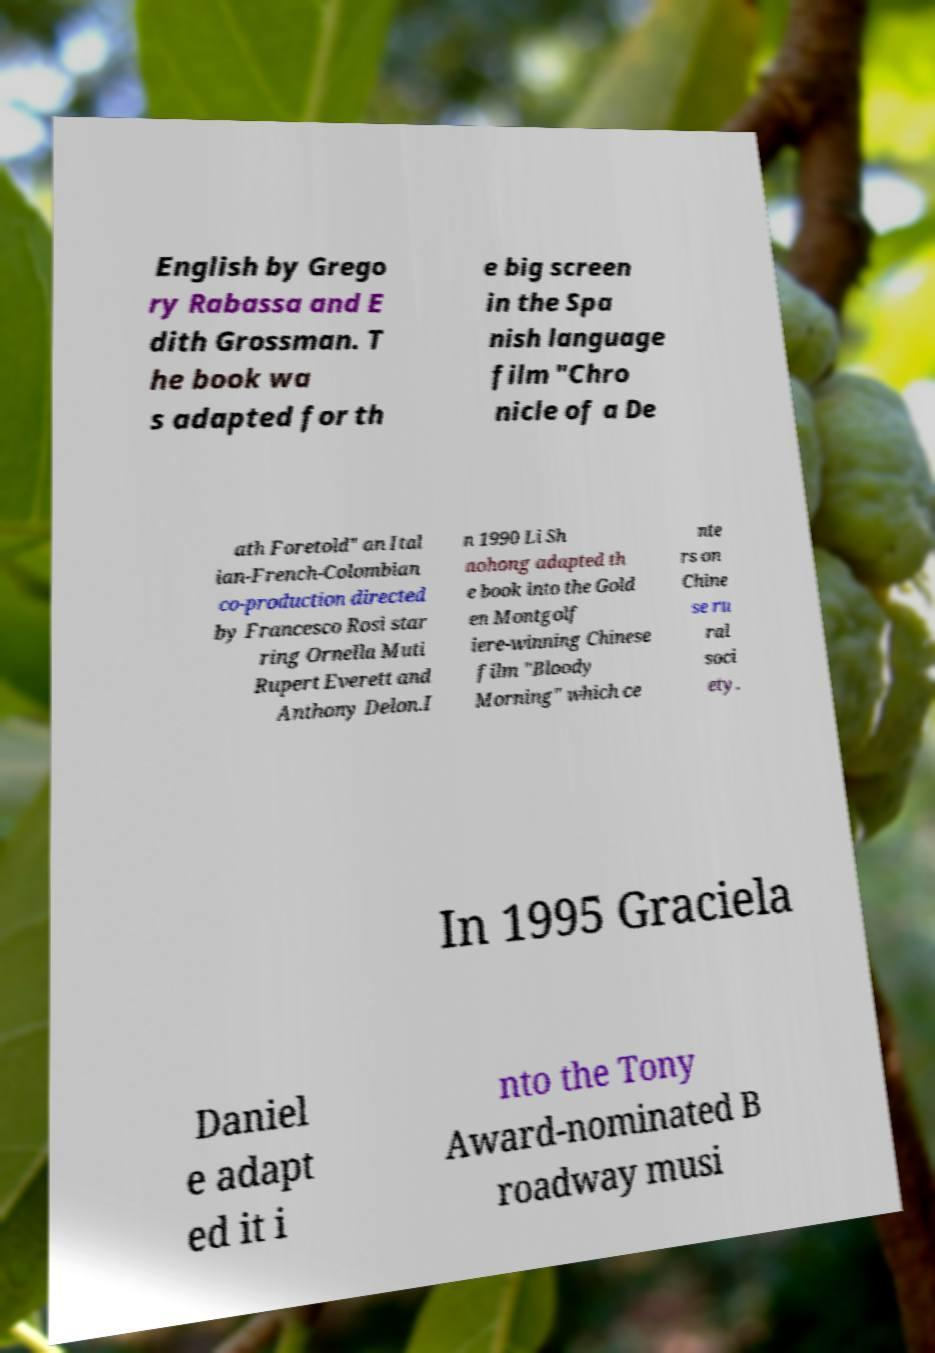Can you read and provide the text displayed in the image?This photo seems to have some interesting text. Can you extract and type it out for me? English by Grego ry Rabassa and E dith Grossman. T he book wa s adapted for th e big screen in the Spa nish language film "Chro nicle of a De ath Foretold" an Ital ian-French-Colombian co-production directed by Francesco Rosi star ring Ornella Muti Rupert Everett and Anthony Delon.I n 1990 Li Sh aohong adapted th e book into the Gold en Montgolf iere-winning Chinese film "Bloody Morning" which ce nte rs on Chine se ru ral soci ety. In 1995 Graciela Daniel e adapt ed it i nto the Tony Award-nominated B roadway musi 